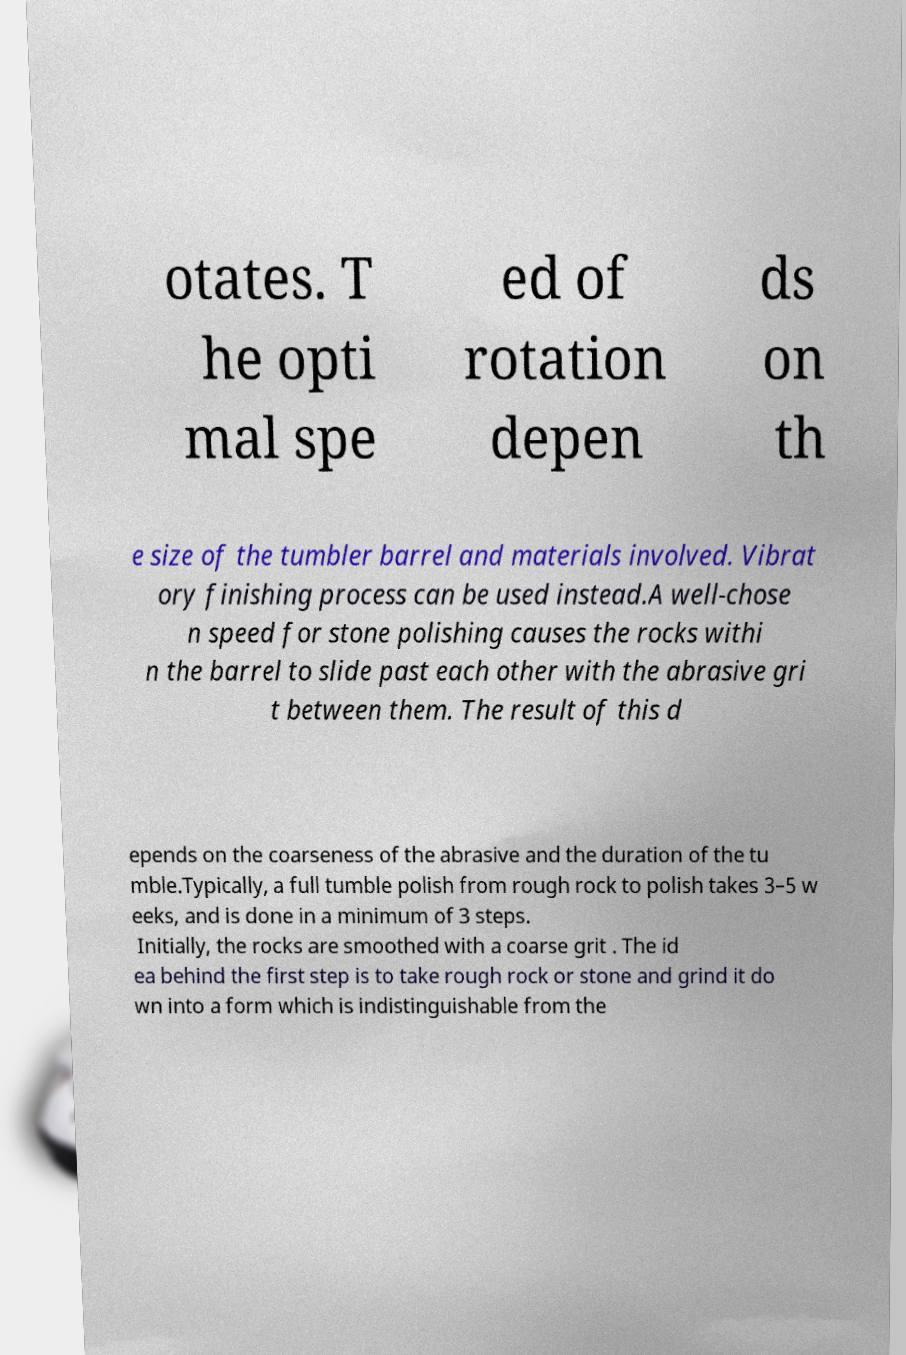Could you assist in decoding the text presented in this image and type it out clearly? otates. T he opti mal spe ed of rotation depen ds on th e size of the tumbler barrel and materials involved. Vibrat ory finishing process can be used instead.A well-chose n speed for stone polishing causes the rocks withi n the barrel to slide past each other with the abrasive gri t between them. The result of this d epends on the coarseness of the abrasive and the duration of the tu mble.Typically, a full tumble polish from rough rock to polish takes 3–5 w eeks, and is done in a minimum of 3 steps. Initially, the rocks are smoothed with a coarse grit . The id ea behind the first step is to take rough rock or stone and grind it do wn into a form which is indistinguishable from the 